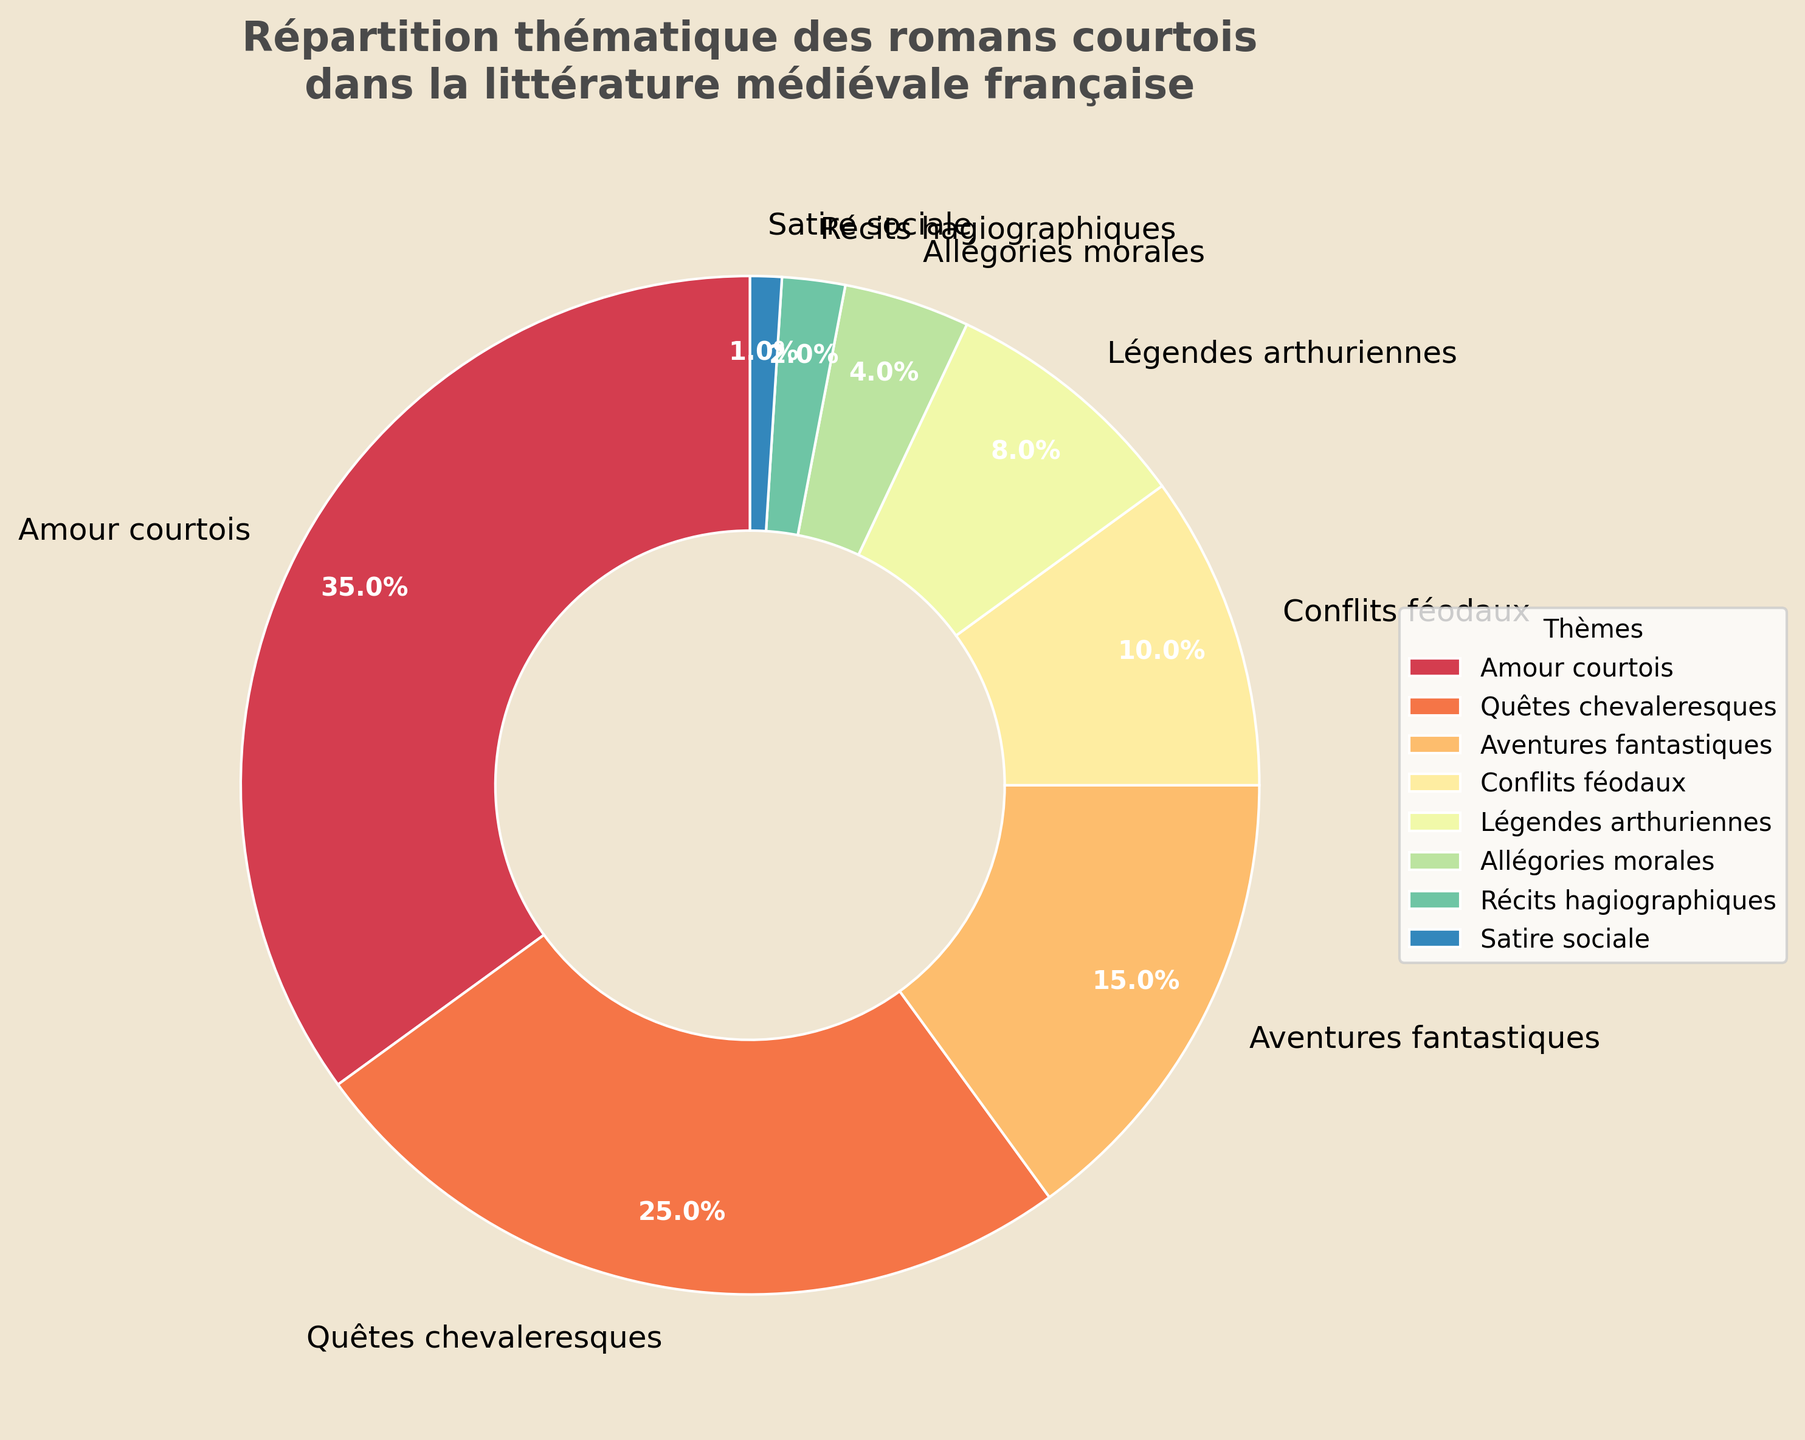Quel thème a le pourcentage le plus élevé ? En regardant les pourcentages sur le diagramme, le "Amour courtois" a la plus grande part avec 35 %.
Answer: Amour courtois Combien de pourcentages sont associés aux thèmes "Quêtes chevaleresques" et "Aventures fantastiques" combinés ? En additionnant les pourcentages de "Quêtes chevaleresques" (25 %) et "Aventures fantastiques" (15 %), on obtient 25 % + 15 % = 40 %.
Answer: 40 % Quel thème a la part la plus petite dans le diagramme ? Le thème avec le plus petit pourcentage sur le diagramme est "Satire sociale" avec 1 %.
Answer: Satire sociale Quels sont les deux premiers thèmes en termes de pourcentage ? Les deux thèmes avec les plus grands pourcentages sont "Amour courtois" (35 %) et "Quêtes chevaleresques" (25 %).
Answer: Amour courtois et Quêtes chevaleresques Quels deux thèmes combinés représentent 18 % ? Additionnant les pourcentages des thèmes "Légendes arthuriennes" (8 %) et "Allégories morales" (4 %), mais c'est insuffisant. Ajoutons "Récits hagiographiques" de 2 % pour atteindre 14 %. "Légendes arthuriennes" (8 %) et "Conflits féodaux" (10 %) donne 18 %.
Answer: Légendes arthuriennes et Conflits féodaux Quel est le thème avec une part de 10 % ? Sur le diagramme, "Conflits féodaux" a une part de 10 %.
Answer: Conflits féodaux Combien de thèmes ont une part inférieure à 5 % ? En vérifiant les pourcentages, les thèmes "Allégories morales" (4 %), "Récits hagiographiques" (2 %), et "Satire sociale" (1 %) sont tous inférieurs à 5 %.
Answer: 3 Quelle est la différence de pourcentage entre "Quêtes chevaleresques" et "Légendes arthuriennes" ? La différence entre "Quêtes chevaleresques" (25 %) et "Légendes arthuriennes" (8 %) est 25 % - 8 % = 17 %.
Answer: 17 % Quel pourcentage combine les thèmes divers et non principaux (ceux qui sont en dessous de 10 %) ? Additionnant les pourcentages sous 10% : "Légendes arthuriennes" (8 %), "Allégories morales" (4 %), "Récits hagiographiques" (2 %), et "Satire sociale" (1 %), on obtient 8 % + 4 % + 2 % + 1 % = 15 %.
Answer: 15 % Quels thèmes constituent plus de la moitié du diagramme ? En additionnant "Amour courtois" (35 %) et "Quêtes chevaleresques" (25 %), on obtient 35 % + 25 % = 60 %, ce qui est plus de la moitié.
Answer: Amour courtois et Quêtes chevaleresques 